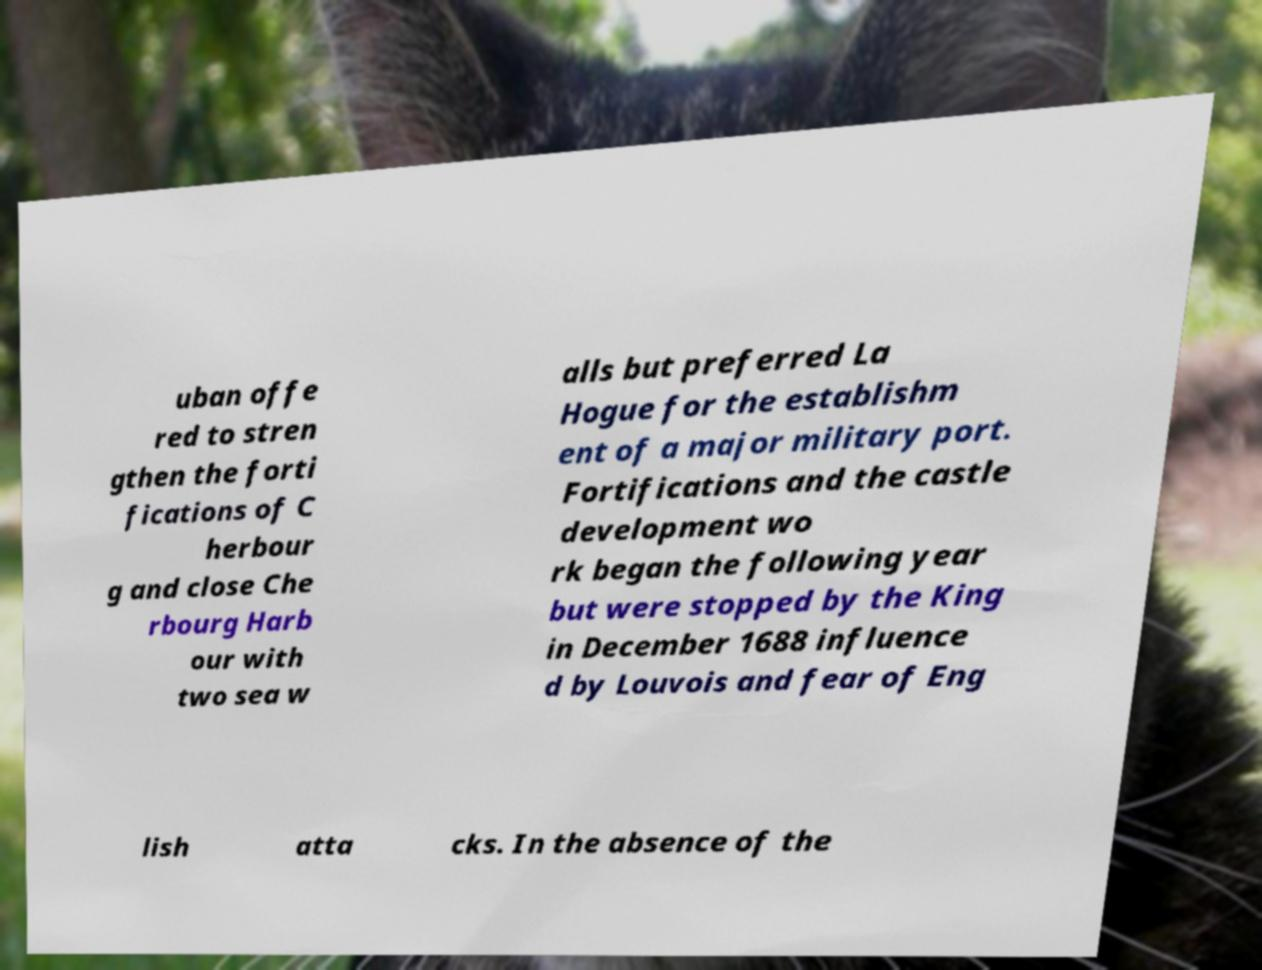Please identify and transcribe the text found in this image. uban offe red to stren gthen the forti fications of C herbour g and close Che rbourg Harb our with two sea w alls but preferred La Hogue for the establishm ent of a major military port. Fortifications and the castle development wo rk began the following year but were stopped by the King in December 1688 influence d by Louvois and fear of Eng lish atta cks. In the absence of the 